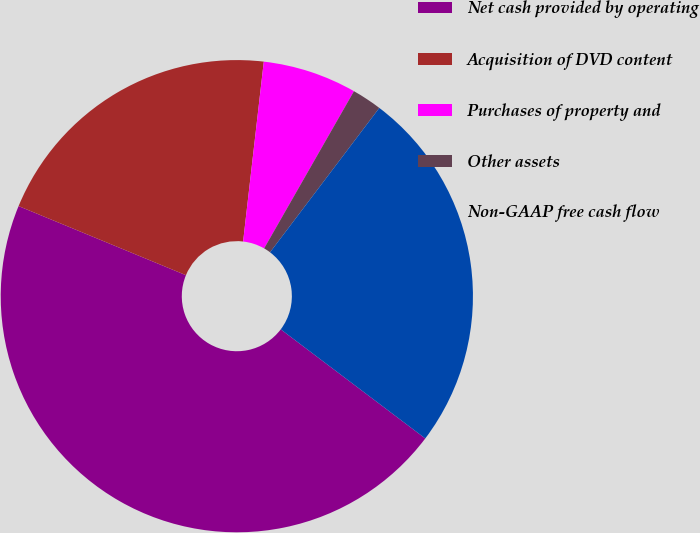<chart> <loc_0><loc_0><loc_500><loc_500><pie_chart><fcel>Net cash provided by operating<fcel>Acquisition of DVD content<fcel>Purchases of property and<fcel>Other assets<fcel>Non-GAAP free cash flow<nl><fcel>45.94%<fcel>20.59%<fcel>6.44%<fcel>2.05%<fcel>24.98%<nl></chart> 